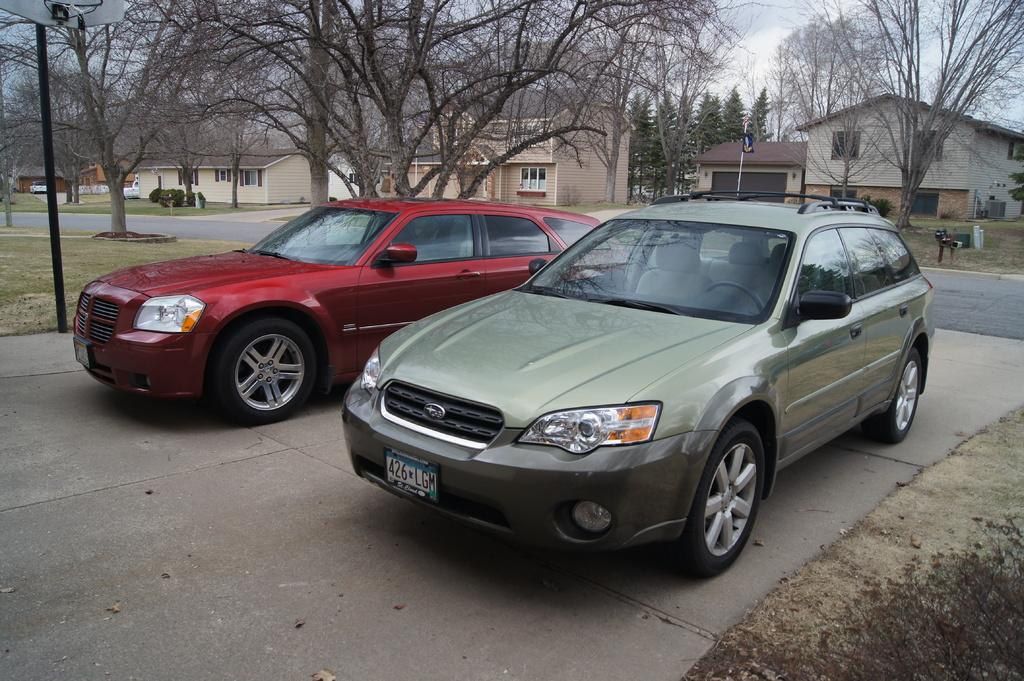What can be seen in the background of the image? In the background of the image, there are houses, trees, and a sky visible. What are some objects present in the image? There are poles, a flag, plants, vehicles, and other objects in the image. What type of surface is visible in the image? There is a road in the image. How many cubes are present in the image? There are no cubes present in the image. What is the wealth of the people living in the houses in the image? The image does not provide any information about the wealth of the people living in the houses. 